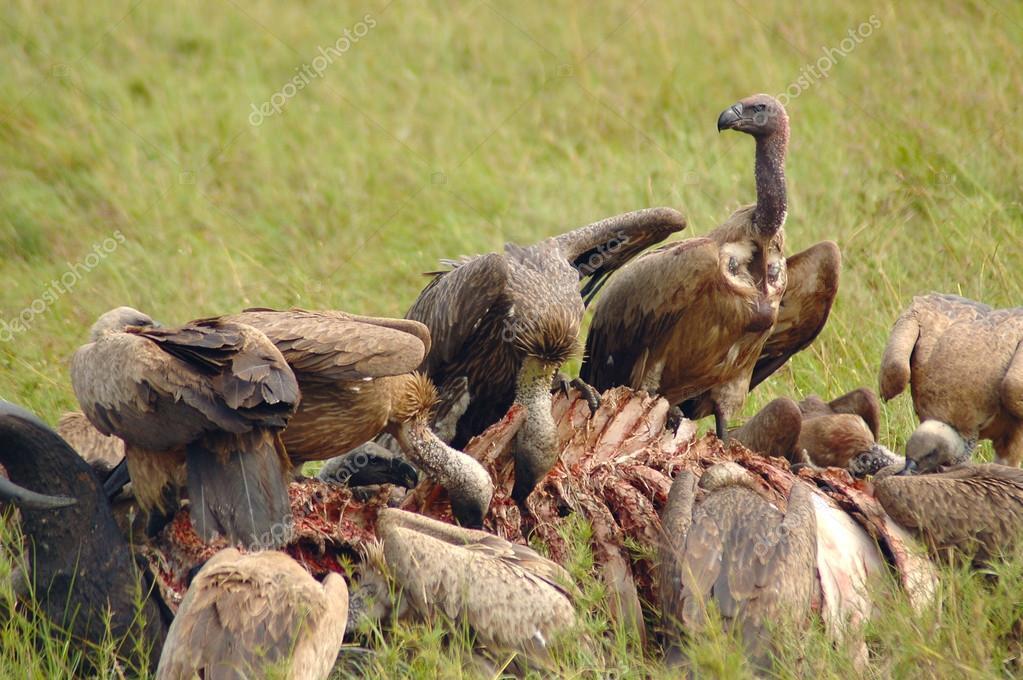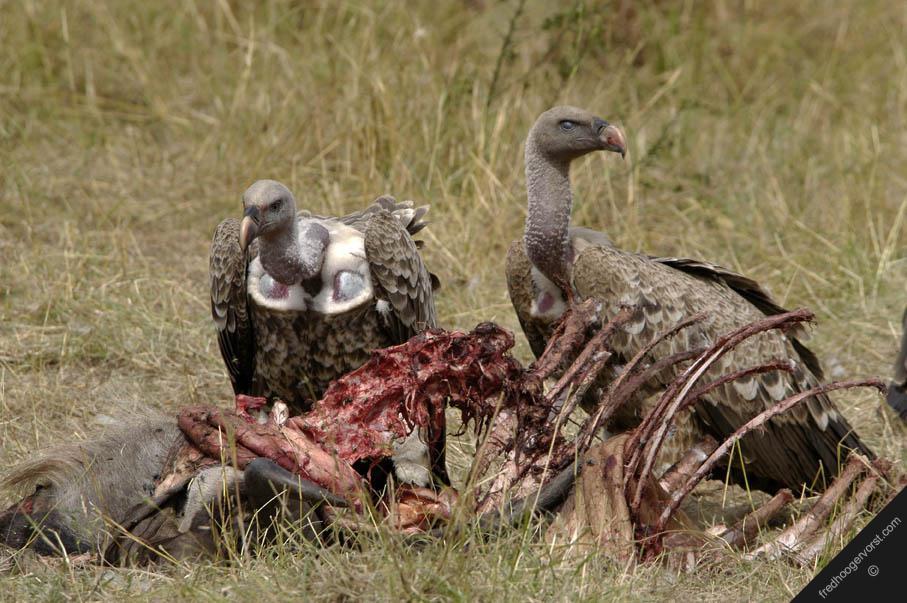The first image is the image on the left, the second image is the image on the right. For the images shown, is this caption "The left image contains exactly two vultures." true? Answer yes or no. No. 